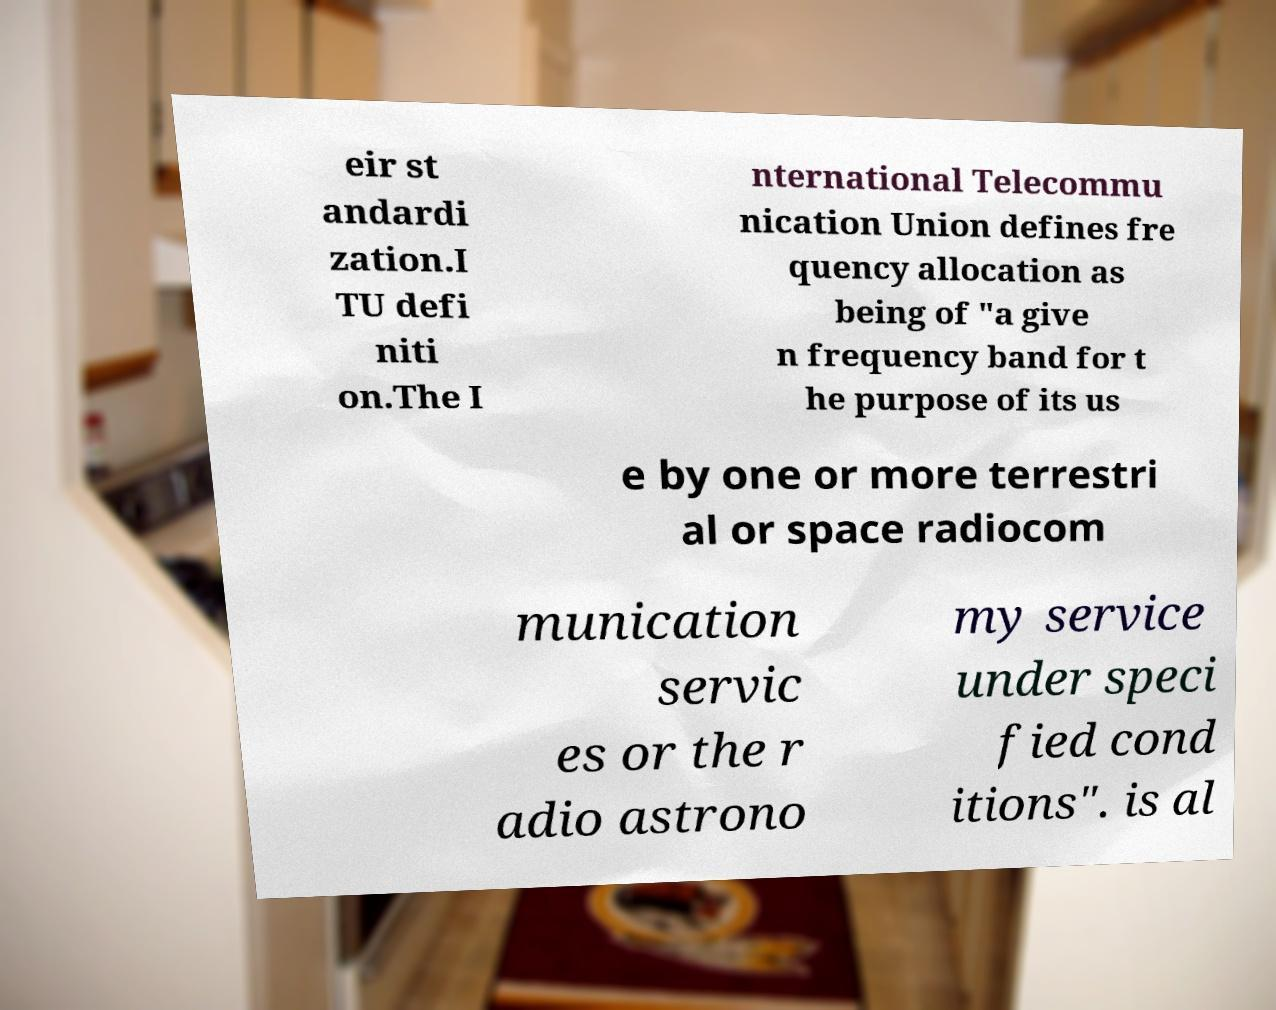Could you assist in decoding the text presented in this image and type it out clearly? eir st andardi zation.I TU defi niti on.The I nternational Telecommu nication Union defines fre quency allocation as being of "a give n frequency band for t he purpose of its us e by one or more terrestri al or space radiocom munication servic es or the r adio astrono my service under speci fied cond itions". is al 